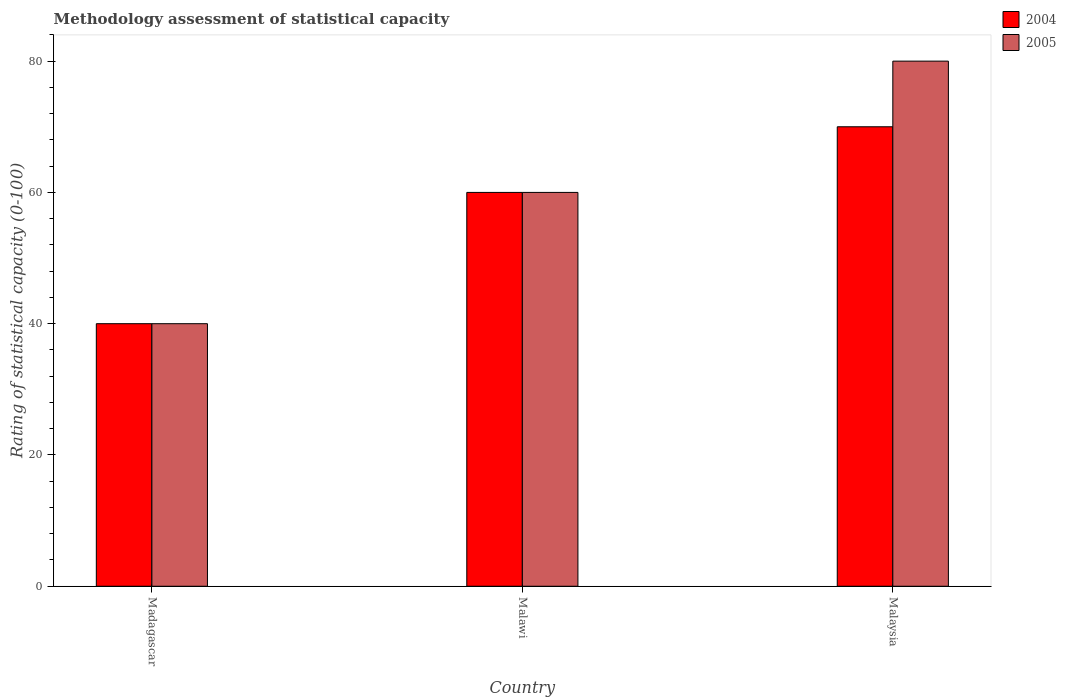How many different coloured bars are there?
Your answer should be very brief. 2. Are the number of bars on each tick of the X-axis equal?
Your answer should be very brief. Yes. How many bars are there on the 1st tick from the right?
Make the answer very short. 2. What is the label of the 1st group of bars from the left?
Make the answer very short. Madagascar. Across all countries, what is the maximum rating of statistical capacity in 2005?
Provide a short and direct response. 80. Across all countries, what is the minimum rating of statistical capacity in 2005?
Ensure brevity in your answer.  40. In which country was the rating of statistical capacity in 2005 maximum?
Offer a terse response. Malaysia. In which country was the rating of statistical capacity in 2005 minimum?
Provide a succinct answer. Madagascar. What is the total rating of statistical capacity in 2004 in the graph?
Offer a terse response. 170. What is the difference between the rating of statistical capacity in 2005 in Malawi and the rating of statistical capacity in 2004 in Malaysia?
Provide a short and direct response. -10. What is the average rating of statistical capacity in 2004 per country?
Offer a terse response. 56.67. What is the difference between the rating of statistical capacity of/in 2005 and rating of statistical capacity of/in 2004 in Malaysia?
Offer a terse response. 10. What is the ratio of the rating of statistical capacity in 2005 in Madagascar to that in Malawi?
Offer a very short reply. 0.67. Is the rating of statistical capacity in 2004 in Madagascar less than that in Malawi?
Keep it short and to the point. Yes. Is the difference between the rating of statistical capacity in 2005 in Malawi and Malaysia greater than the difference between the rating of statistical capacity in 2004 in Malawi and Malaysia?
Your answer should be compact. No. What is the difference between the highest and the second highest rating of statistical capacity in 2005?
Give a very brief answer. 40. In how many countries, is the rating of statistical capacity in 2004 greater than the average rating of statistical capacity in 2004 taken over all countries?
Offer a terse response. 2. Is the sum of the rating of statistical capacity in 2005 in Malawi and Malaysia greater than the maximum rating of statistical capacity in 2004 across all countries?
Provide a succinct answer. Yes. How many countries are there in the graph?
Make the answer very short. 3. What is the difference between two consecutive major ticks on the Y-axis?
Provide a short and direct response. 20. Does the graph contain any zero values?
Keep it short and to the point. No. Does the graph contain grids?
Your answer should be very brief. No. Where does the legend appear in the graph?
Give a very brief answer. Top right. What is the title of the graph?
Provide a short and direct response. Methodology assessment of statistical capacity. What is the label or title of the Y-axis?
Make the answer very short. Rating of statistical capacity (0-100). What is the Rating of statistical capacity (0-100) of 2004 in Malawi?
Give a very brief answer. 60. What is the Rating of statistical capacity (0-100) in 2005 in Malawi?
Your response must be concise. 60. What is the Rating of statistical capacity (0-100) of 2005 in Malaysia?
Your response must be concise. 80. Across all countries, what is the maximum Rating of statistical capacity (0-100) in 2004?
Your answer should be very brief. 70. Across all countries, what is the maximum Rating of statistical capacity (0-100) of 2005?
Your response must be concise. 80. What is the total Rating of statistical capacity (0-100) in 2004 in the graph?
Offer a terse response. 170. What is the total Rating of statistical capacity (0-100) in 2005 in the graph?
Your response must be concise. 180. What is the difference between the Rating of statistical capacity (0-100) in 2005 in Madagascar and that in Malawi?
Provide a succinct answer. -20. What is the difference between the Rating of statistical capacity (0-100) of 2005 in Madagascar and that in Malaysia?
Your answer should be very brief. -40. What is the difference between the Rating of statistical capacity (0-100) in 2004 in Malawi and that in Malaysia?
Your answer should be compact. -10. What is the difference between the Rating of statistical capacity (0-100) in 2005 in Malawi and that in Malaysia?
Offer a very short reply. -20. What is the difference between the Rating of statistical capacity (0-100) of 2004 in Madagascar and the Rating of statistical capacity (0-100) of 2005 in Malaysia?
Provide a succinct answer. -40. What is the average Rating of statistical capacity (0-100) of 2004 per country?
Provide a succinct answer. 56.67. What is the average Rating of statistical capacity (0-100) in 2005 per country?
Your answer should be very brief. 60. What is the difference between the Rating of statistical capacity (0-100) in 2004 and Rating of statistical capacity (0-100) in 2005 in Malawi?
Provide a succinct answer. 0. What is the difference between the Rating of statistical capacity (0-100) of 2004 and Rating of statistical capacity (0-100) of 2005 in Malaysia?
Give a very brief answer. -10. What is the ratio of the Rating of statistical capacity (0-100) in 2004 in Madagascar to that in Malawi?
Your response must be concise. 0.67. What is the ratio of the Rating of statistical capacity (0-100) of 2004 in Madagascar to that in Malaysia?
Offer a very short reply. 0.57. What is the ratio of the Rating of statistical capacity (0-100) in 2005 in Madagascar to that in Malaysia?
Offer a terse response. 0.5. What is the ratio of the Rating of statistical capacity (0-100) in 2005 in Malawi to that in Malaysia?
Make the answer very short. 0.75. What is the difference between the highest and the lowest Rating of statistical capacity (0-100) in 2005?
Keep it short and to the point. 40. 